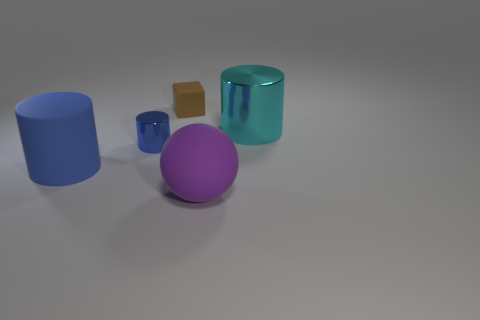What shape is the big thing in front of the large blue rubber thing?
Your answer should be very brief. Sphere. What material is the blue thing left of the tiny thing that is in front of the tiny brown object?
Provide a short and direct response. Rubber. Are there more large things left of the cyan metallic cylinder than brown metallic objects?
Your answer should be very brief. Yes. How many other objects are there of the same color as the matte cylinder?
Give a very brief answer. 1. There is a blue matte thing that is the same size as the cyan metal thing; what shape is it?
Provide a short and direct response. Cylinder. There is a object on the left side of the blue cylinder behind the big rubber cylinder; what number of purple things are in front of it?
Your answer should be compact. 1. What number of metal things are either tiny purple objects or small blue cylinders?
Make the answer very short. 1. What is the color of the cylinder that is behind the large blue matte cylinder and on the left side of the purple matte ball?
Offer a very short reply. Blue. There is a metal cylinder left of the cyan metal object; is its size the same as the large purple object?
Offer a very short reply. No. What number of objects are large cylinders to the left of the matte block or small brown rubber blocks?
Provide a succinct answer. 2. 